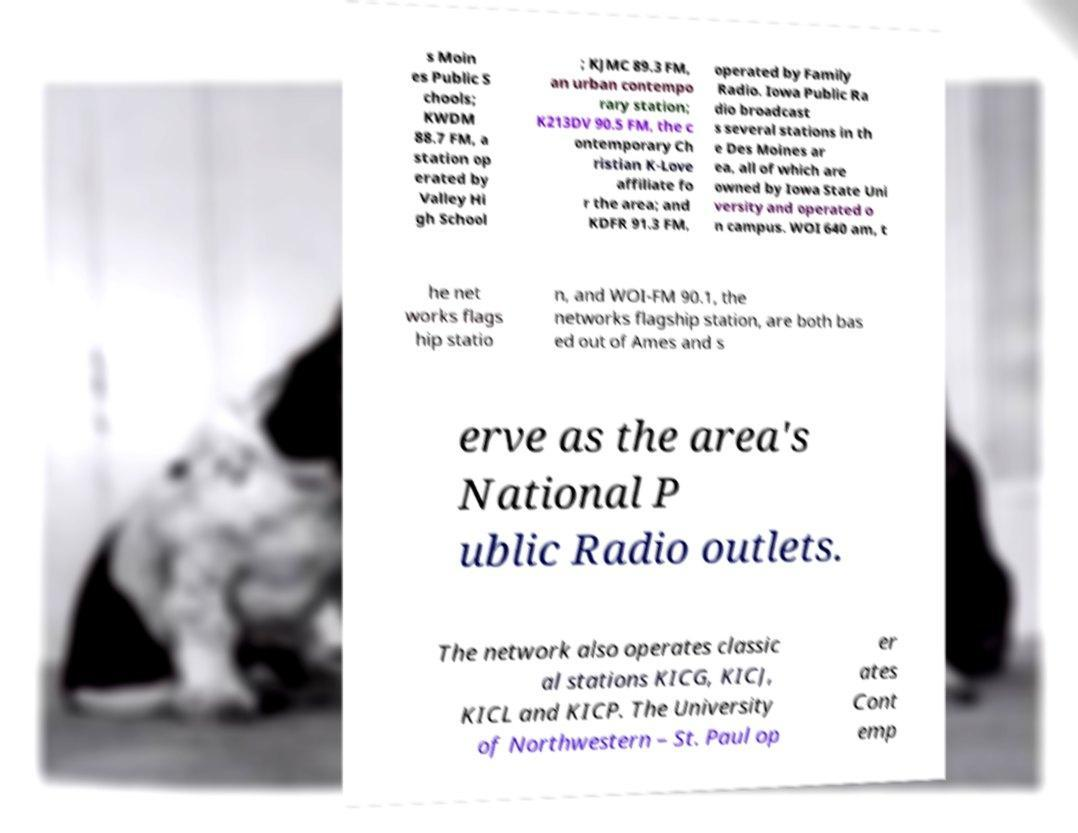Can you accurately transcribe the text from the provided image for me? s Moin es Public S chools; KWDM 88.7 FM, a station op erated by Valley Hi gh School ; KJMC 89.3 FM, an urban contempo rary station; K213DV 90.5 FM, the c ontemporary Ch ristian K-Love affiliate fo r the area; and KDFR 91.3 FM, operated by Family Radio. Iowa Public Ra dio broadcast s several stations in th e Des Moines ar ea, all of which are owned by Iowa State Uni versity and operated o n campus. WOI 640 am, t he net works flags hip statio n, and WOI-FM 90.1, the networks flagship station, are both bas ed out of Ames and s erve as the area's National P ublic Radio outlets. The network also operates classic al stations KICG, KICJ, KICL and KICP. The University of Northwestern – St. Paul op er ates Cont emp 